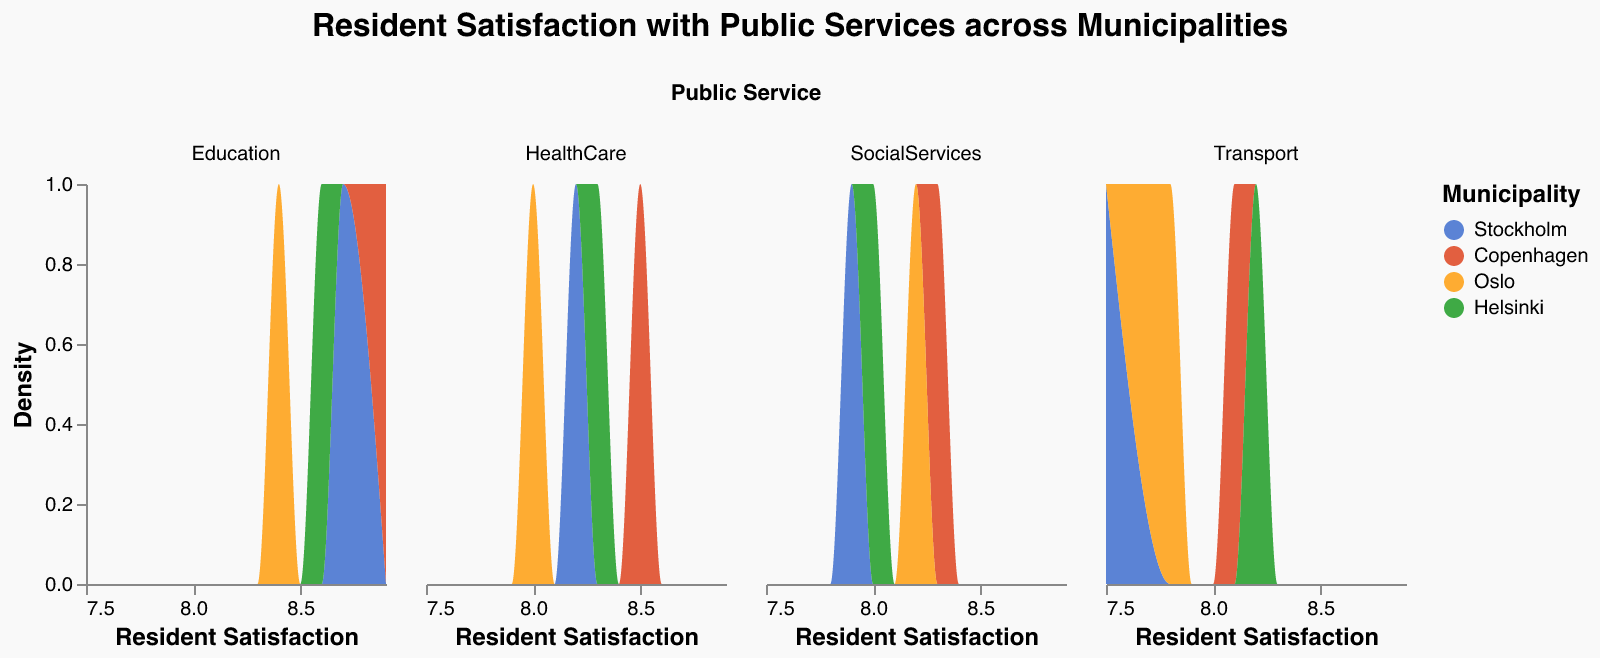How many municipalities are represented in the figure? There are four distinct colors in the figure, each representing a different municipality: Stockholm, Copenhagen, Oslo, and Helsinki.
Answer: Four In which municipality is resident satisfaction with Education the highest? By looking at the density plot specific to Education, we can see that the peak or highest density is in Copenhagen.
Answer: Copenhagen What is the range of resident satisfaction with Transport in Oslo? The density plot for Transport in Oslo shows data points between the lowest satisfaction at 7.8 and highest around 7.8 (with no higher domain).
Answer: 7.8 Which public service has the highest variance in resident satisfaction across municipalities? Comparing the spread or width of the density plots for each public service, we can see that Transport has the widest spread, indicating the highest variance in resident satisfaction.
Answer: Transport Does Helsinki have any public service where resident satisfaction stands out compared to other municipalities? Helsinki consistently scores high across all services, but it doesn't stand out dramatically in any specific service compared to other municipalities.
Answer: No For which public service do all municipalities show a similar resident satisfaction level? By looking at all public service density plots, we can see that the satisfaction levels for Social Services are closely grouped together for all municipalities reflecting similar satisfaction.
Answer: Social Services Which municipality has the lowest satisfaction with Transport? In the density plot for Transport, Stockholm shows the lowest peak in resident satisfaction.
Answer: Stockholm Which public service has the maximum overall satisfaction across all municipalities? By looking across all density plots, Education in Copenhagen stands out with the highest peaks in resident satisfaction.
Answer: Education Is there a public service where the satisfaction scores are uniformly distributed across all municipalities? By examining the density plots, we can observe that HealthCare has a relatively uniform distribution of satisfaction scores across all municipalities.
Answer: HealthCare Comparing Education and Transport, in which municipality do we see the greatest discrepancy in resident satisfaction? By looking at both density plots, Stockholm shows a significant difference with higher satisfaction in Education and lower in Transport.
Answer: Stockholm 